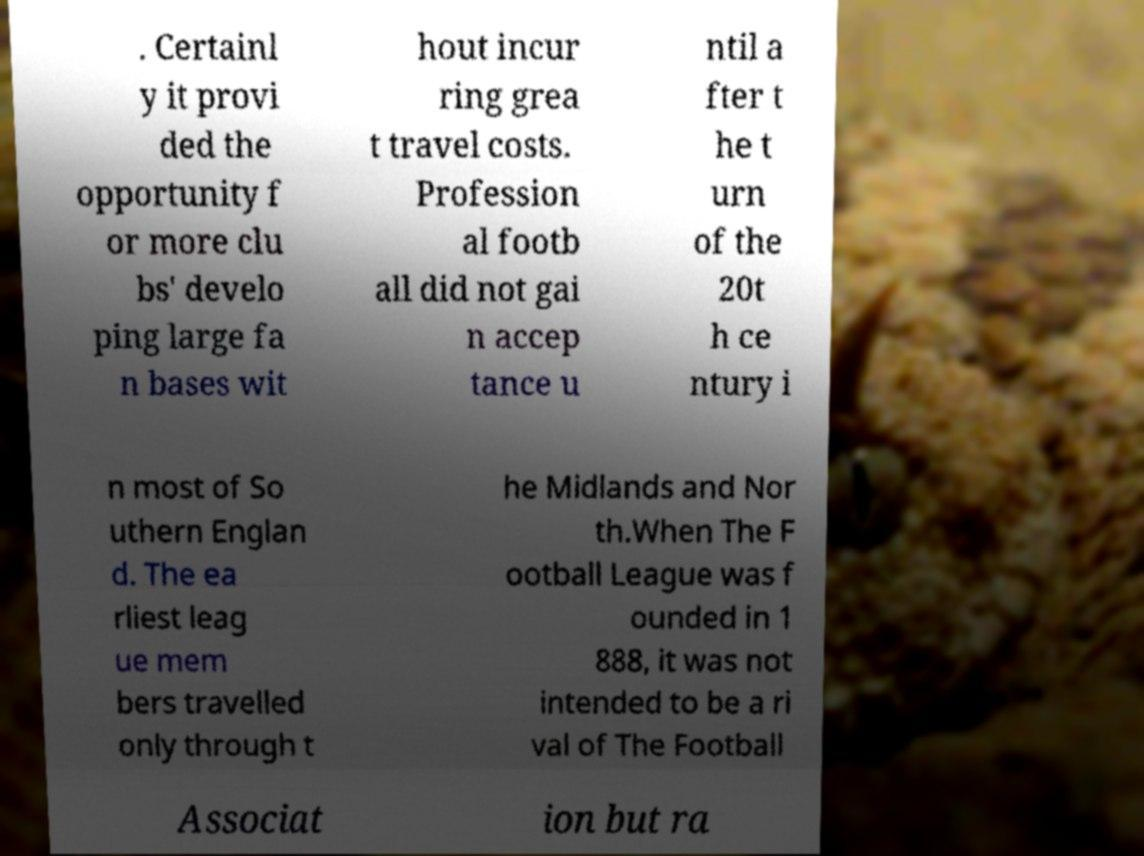Can you accurately transcribe the text from the provided image for me? . Certainl y it provi ded the opportunity f or more clu bs' develo ping large fa n bases wit hout incur ring grea t travel costs. Profession al footb all did not gai n accep tance u ntil a fter t he t urn of the 20t h ce ntury i n most of So uthern Englan d. The ea rliest leag ue mem bers travelled only through t he Midlands and Nor th.When The F ootball League was f ounded in 1 888, it was not intended to be a ri val of The Football Associat ion but ra 